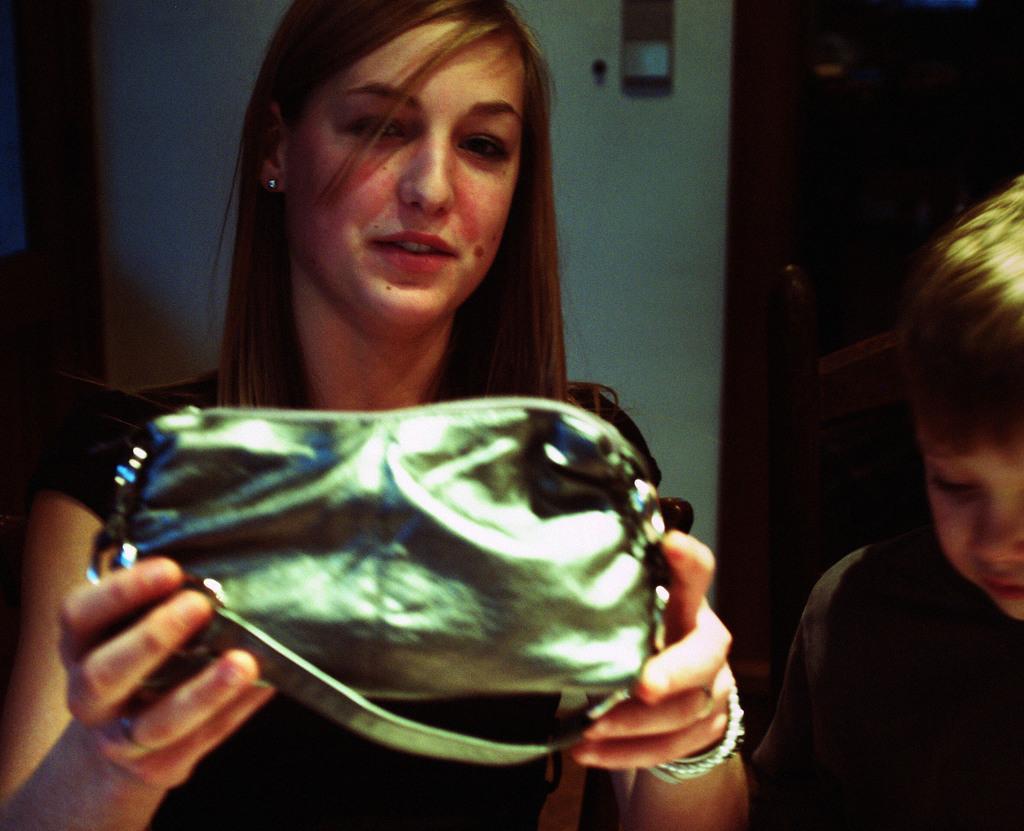In one or two sentences, can you explain what this image depicts? In this picture we can see a woman standing and holding a purse in her hands, and at beside a boy is standing. 